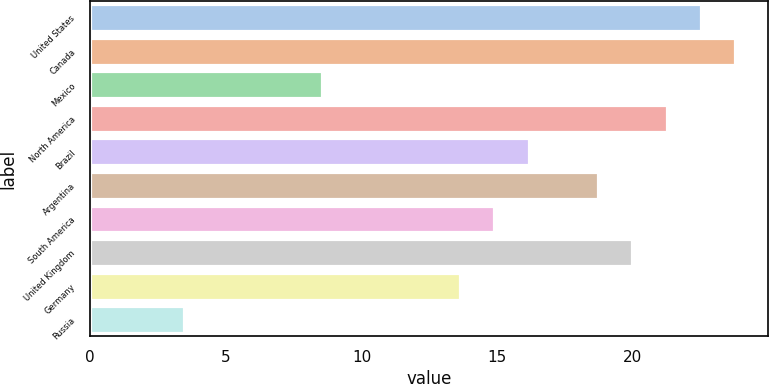<chart> <loc_0><loc_0><loc_500><loc_500><bar_chart><fcel>United States<fcel>Canada<fcel>Mexico<fcel>North America<fcel>Brazil<fcel>Argentina<fcel>South America<fcel>United Kingdom<fcel>Germany<fcel>Russia<nl><fcel>22.52<fcel>23.79<fcel>8.55<fcel>21.25<fcel>16.17<fcel>18.71<fcel>14.9<fcel>19.98<fcel>13.63<fcel>3.47<nl></chart> 